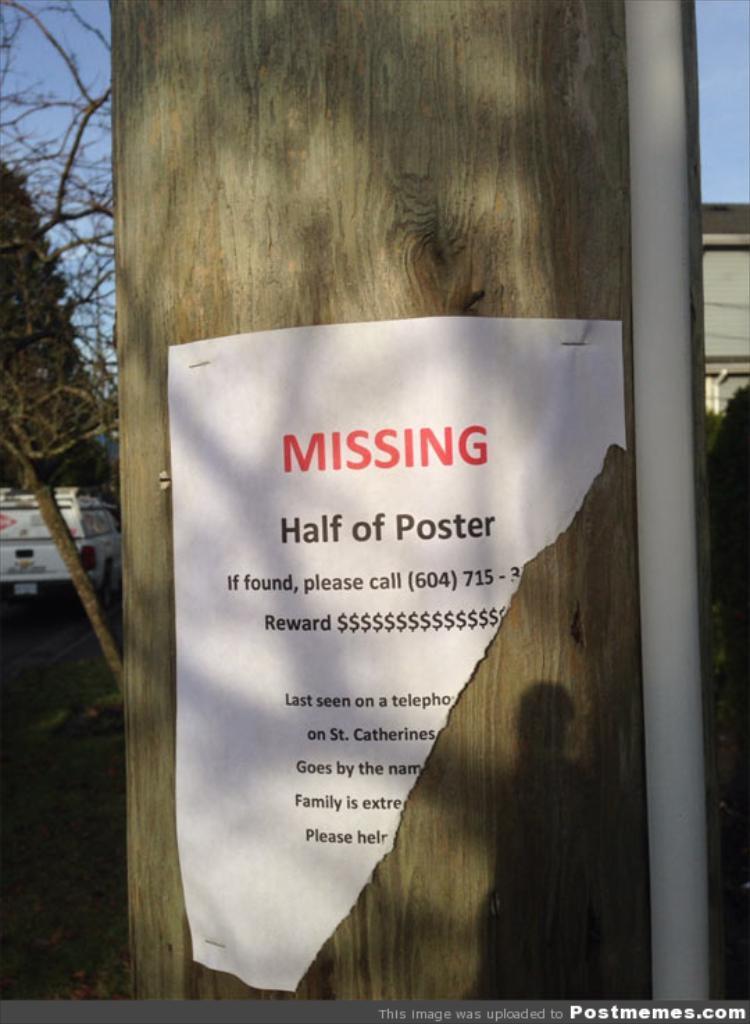Could you give a brief overview of what you see in this image? In this picture, We can see a big tree trunk, On tree trunk we can see a piece of paper which is sticked and there is something written on it and we can see iron pole and towards left i can see a white color vehicle and a tree. 